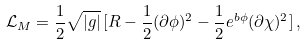<formula> <loc_0><loc_0><loc_500><loc_500>\mathcal { L } _ { M } = \frac { 1 } { 2 } \sqrt { | g | } \, [ { R } - \frac { 1 } { 2 } ( \partial { \phi } ) ^ { 2 } - \frac { 1 } { 2 } e ^ { b { \phi } } ( \partial { \chi } ) ^ { 2 } ] \, ,</formula> 